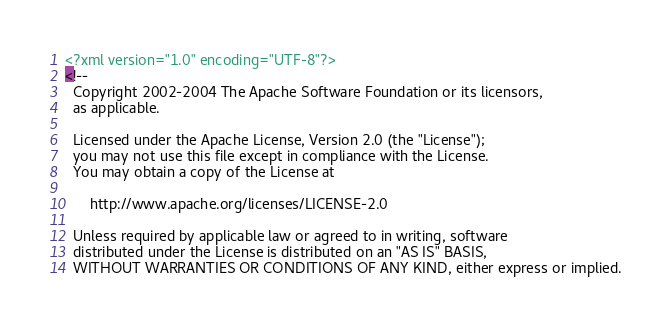Convert code to text. <code><loc_0><loc_0><loc_500><loc_500><_XML_><?xml version="1.0" encoding="UTF-8"?>
<!--
  Copyright 2002-2004 The Apache Software Foundation or its licensors,
  as applicable.

  Licensed under the Apache License, Version 2.0 (the "License");
  you may not use this file except in compliance with the License.
  You may obtain a copy of the License at

      http://www.apache.org/licenses/LICENSE-2.0

  Unless required by applicable law or agreed to in writing, software
  distributed under the License is distributed on an "AS IS" BASIS,
  WITHOUT WARRANTIES OR CONDITIONS OF ANY KIND, either express or implied.</code> 